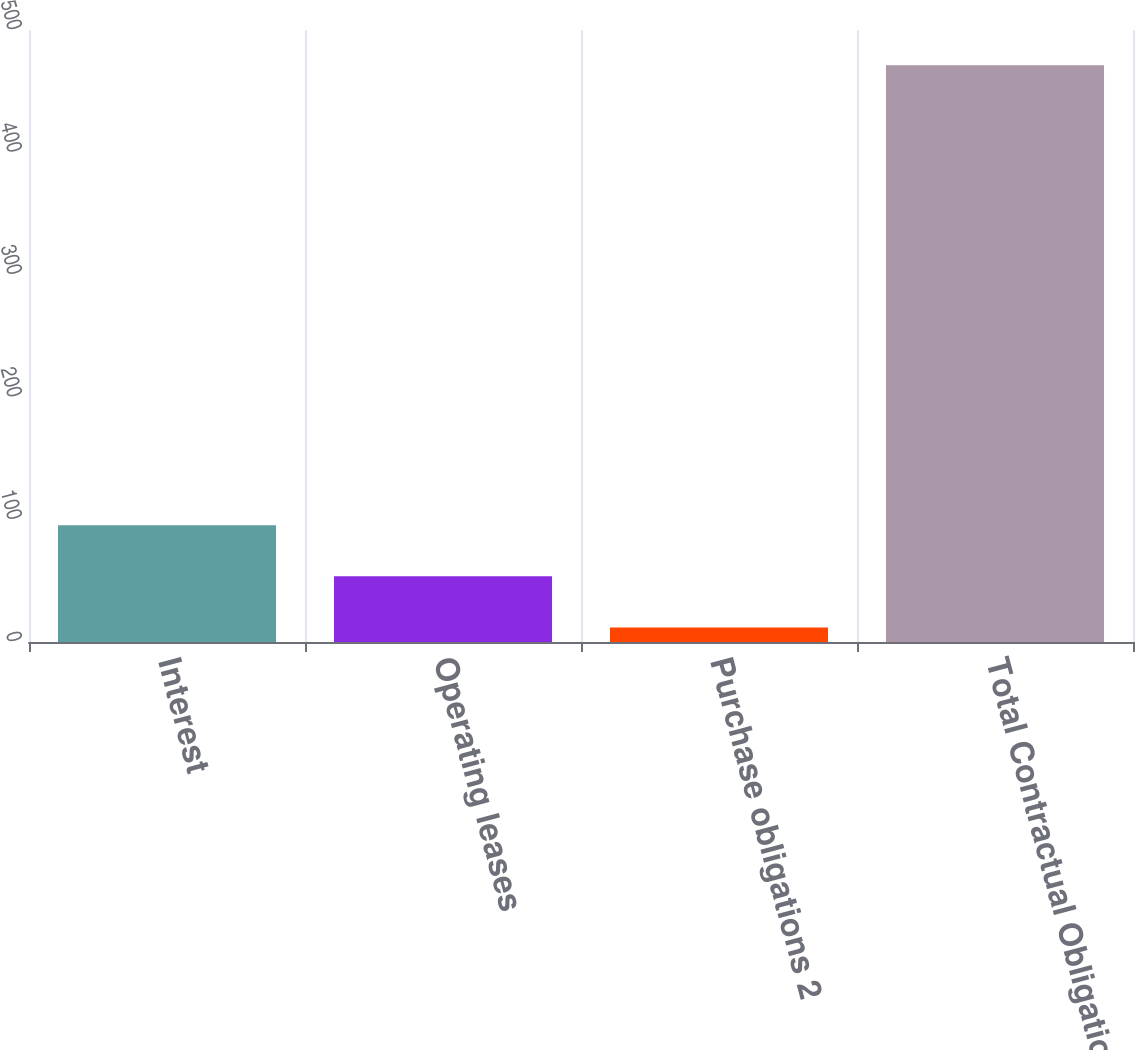Convert chart. <chart><loc_0><loc_0><loc_500><loc_500><bar_chart><fcel>Interest<fcel>Operating leases<fcel>Purchase obligations 2<fcel>Total Contractual Obligations<nl><fcel>95.4<fcel>53.65<fcel>11.9<fcel>471.15<nl></chart> 